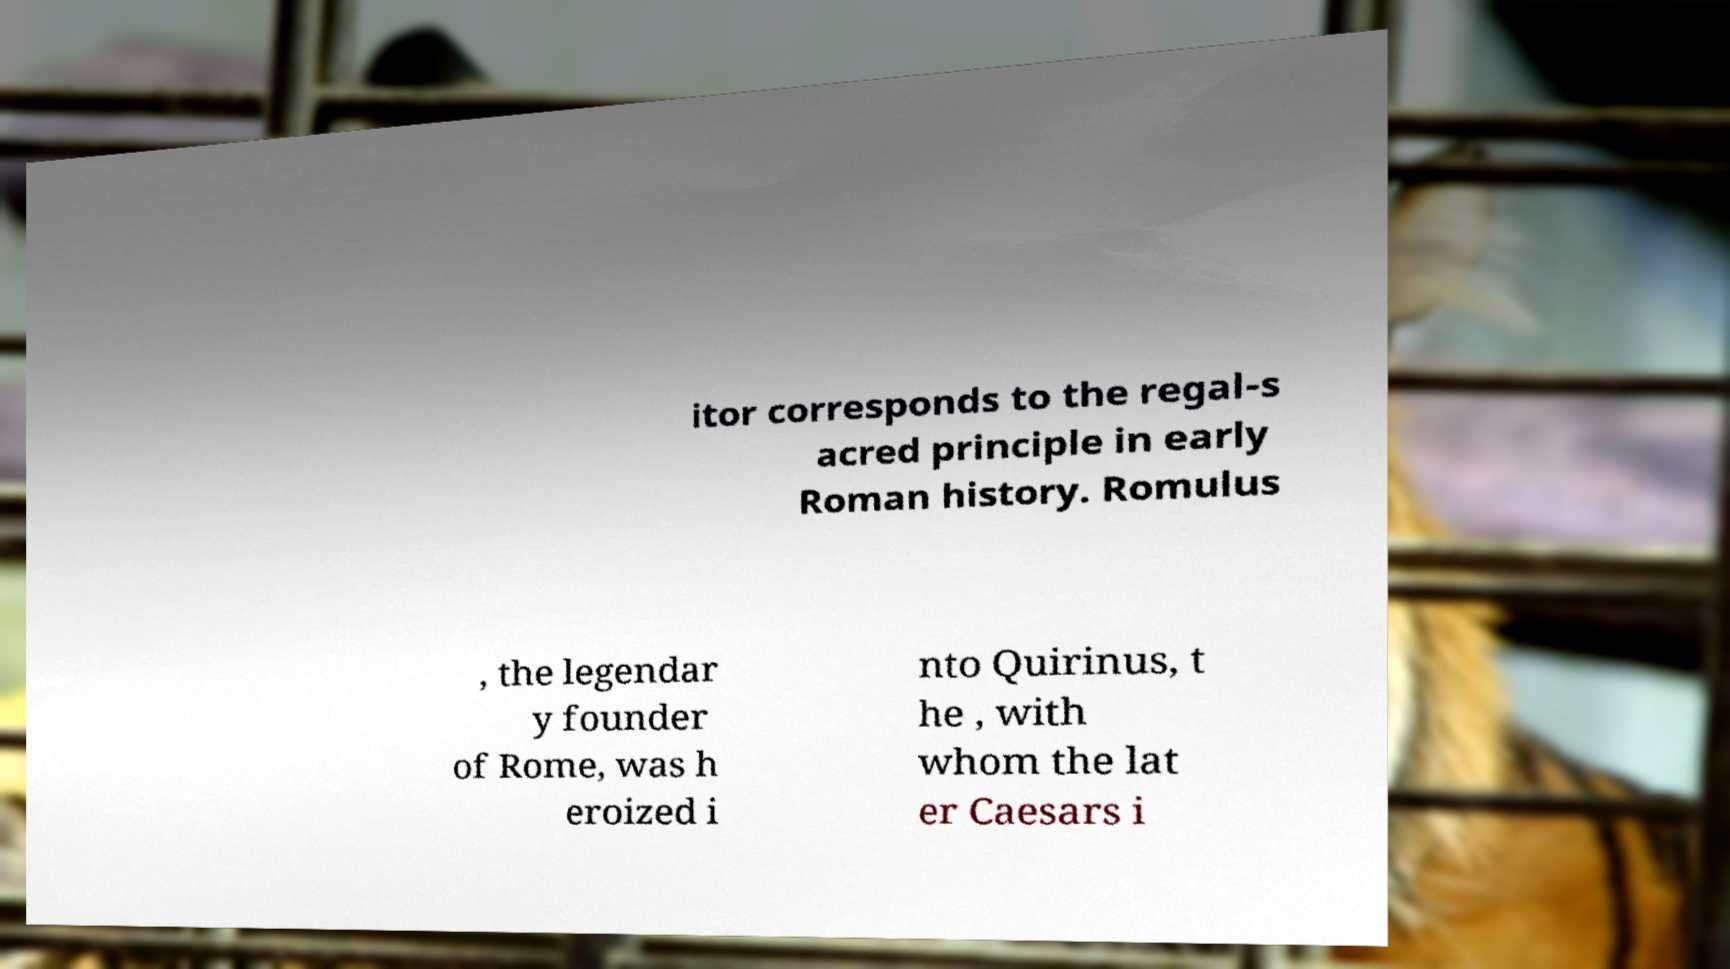Please identify and transcribe the text found in this image. itor corresponds to the regal-s acred principle in early Roman history. Romulus , the legendar y founder of Rome, was h eroized i nto Quirinus, t he , with whom the lat er Caesars i 